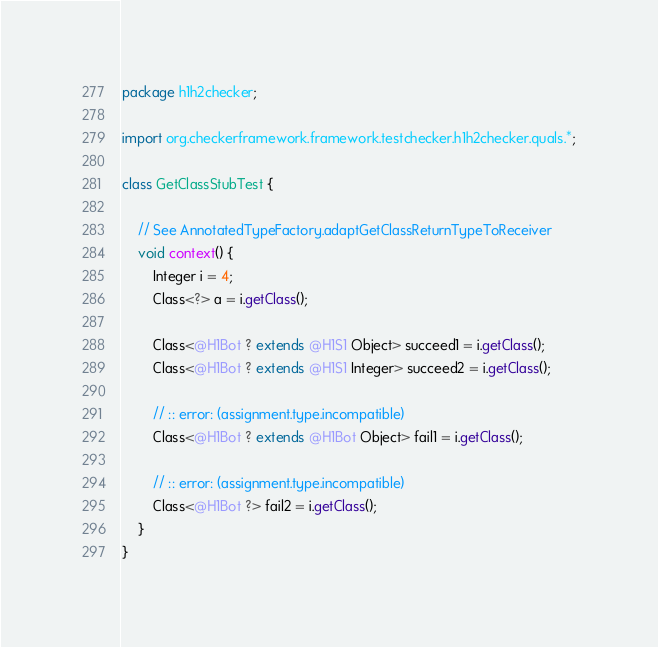Convert code to text. <code><loc_0><loc_0><loc_500><loc_500><_Java_>package h1h2checker;

import org.checkerframework.framework.testchecker.h1h2checker.quals.*;

class GetClassStubTest {

    // See AnnotatedTypeFactory.adaptGetClassReturnTypeToReceiver
    void context() {
        Integer i = 4;
        Class<?> a = i.getClass();

        Class<@H1Bot ? extends @H1S1 Object> succeed1 = i.getClass();
        Class<@H1Bot ? extends @H1S1 Integer> succeed2 = i.getClass();

        // :: error: (assignment.type.incompatible)
        Class<@H1Bot ? extends @H1Bot Object> fail1 = i.getClass();

        // :: error: (assignment.type.incompatible)
        Class<@H1Bot ?> fail2 = i.getClass();
    }
}
</code> 